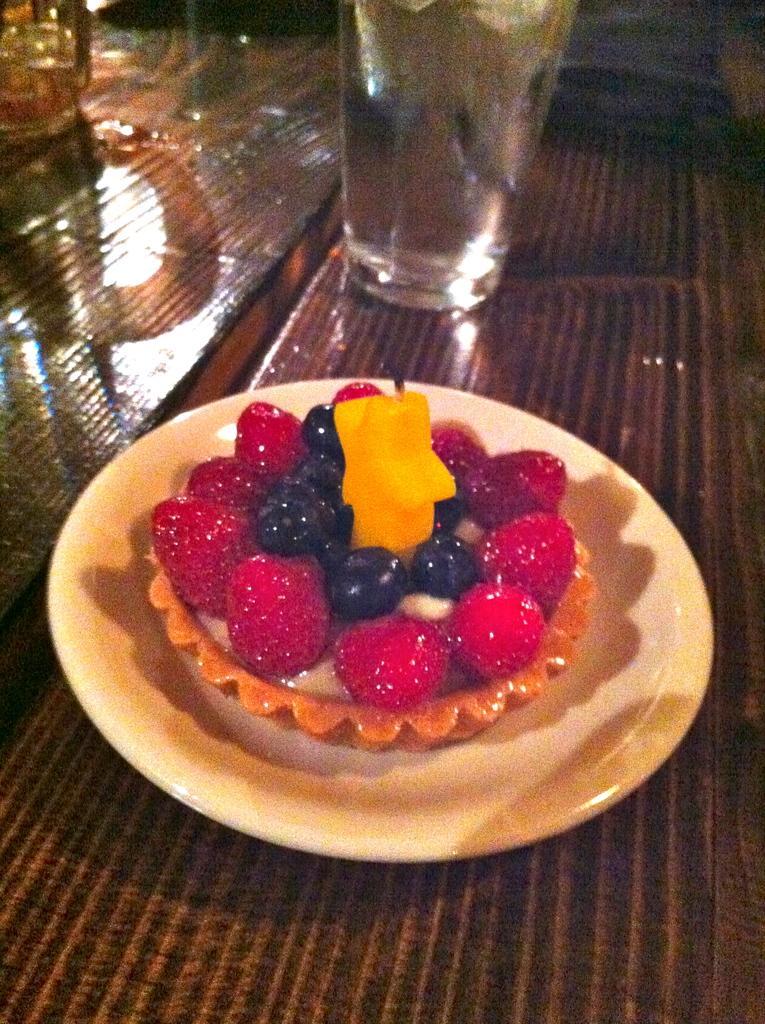Please provide a concise description of this image. In this picture we can see a plate with food items on it, glasses and these all are placed on a table. 